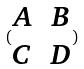<formula> <loc_0><loc_0><loc_500><loc_500>( \begin{matrix} A & B \\ C & D \end{matrix} )</formula> 